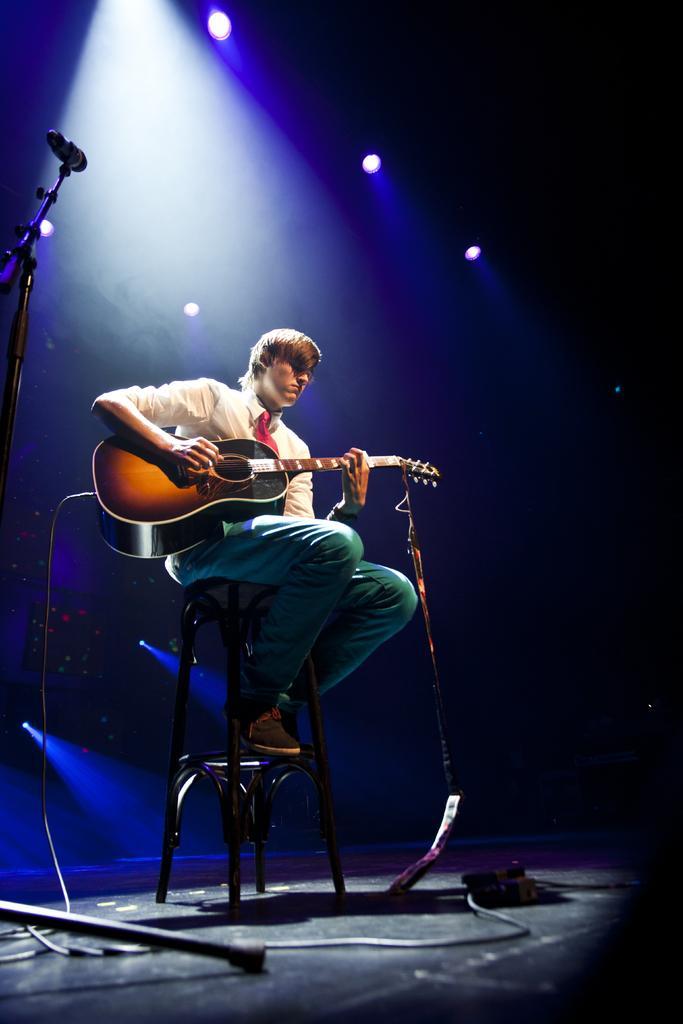Can you describe this image briefly? This image is clicked at a stage performance. In the middle there is a man he wear white shirt,tie and trouser he is playing guitar he is sitting. On the left there is a mic. In the background there are many lights. 